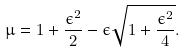Convert formula to latex. <formula><loc_0><loc_0><loc_500><loc_500>\mu = 1 + \frac { \epsilon ^ { 2 } } 2 - \epsilon \sqrt { 1 + \frac { \epsilon ^ { 2 } } 4 } .</formula> 